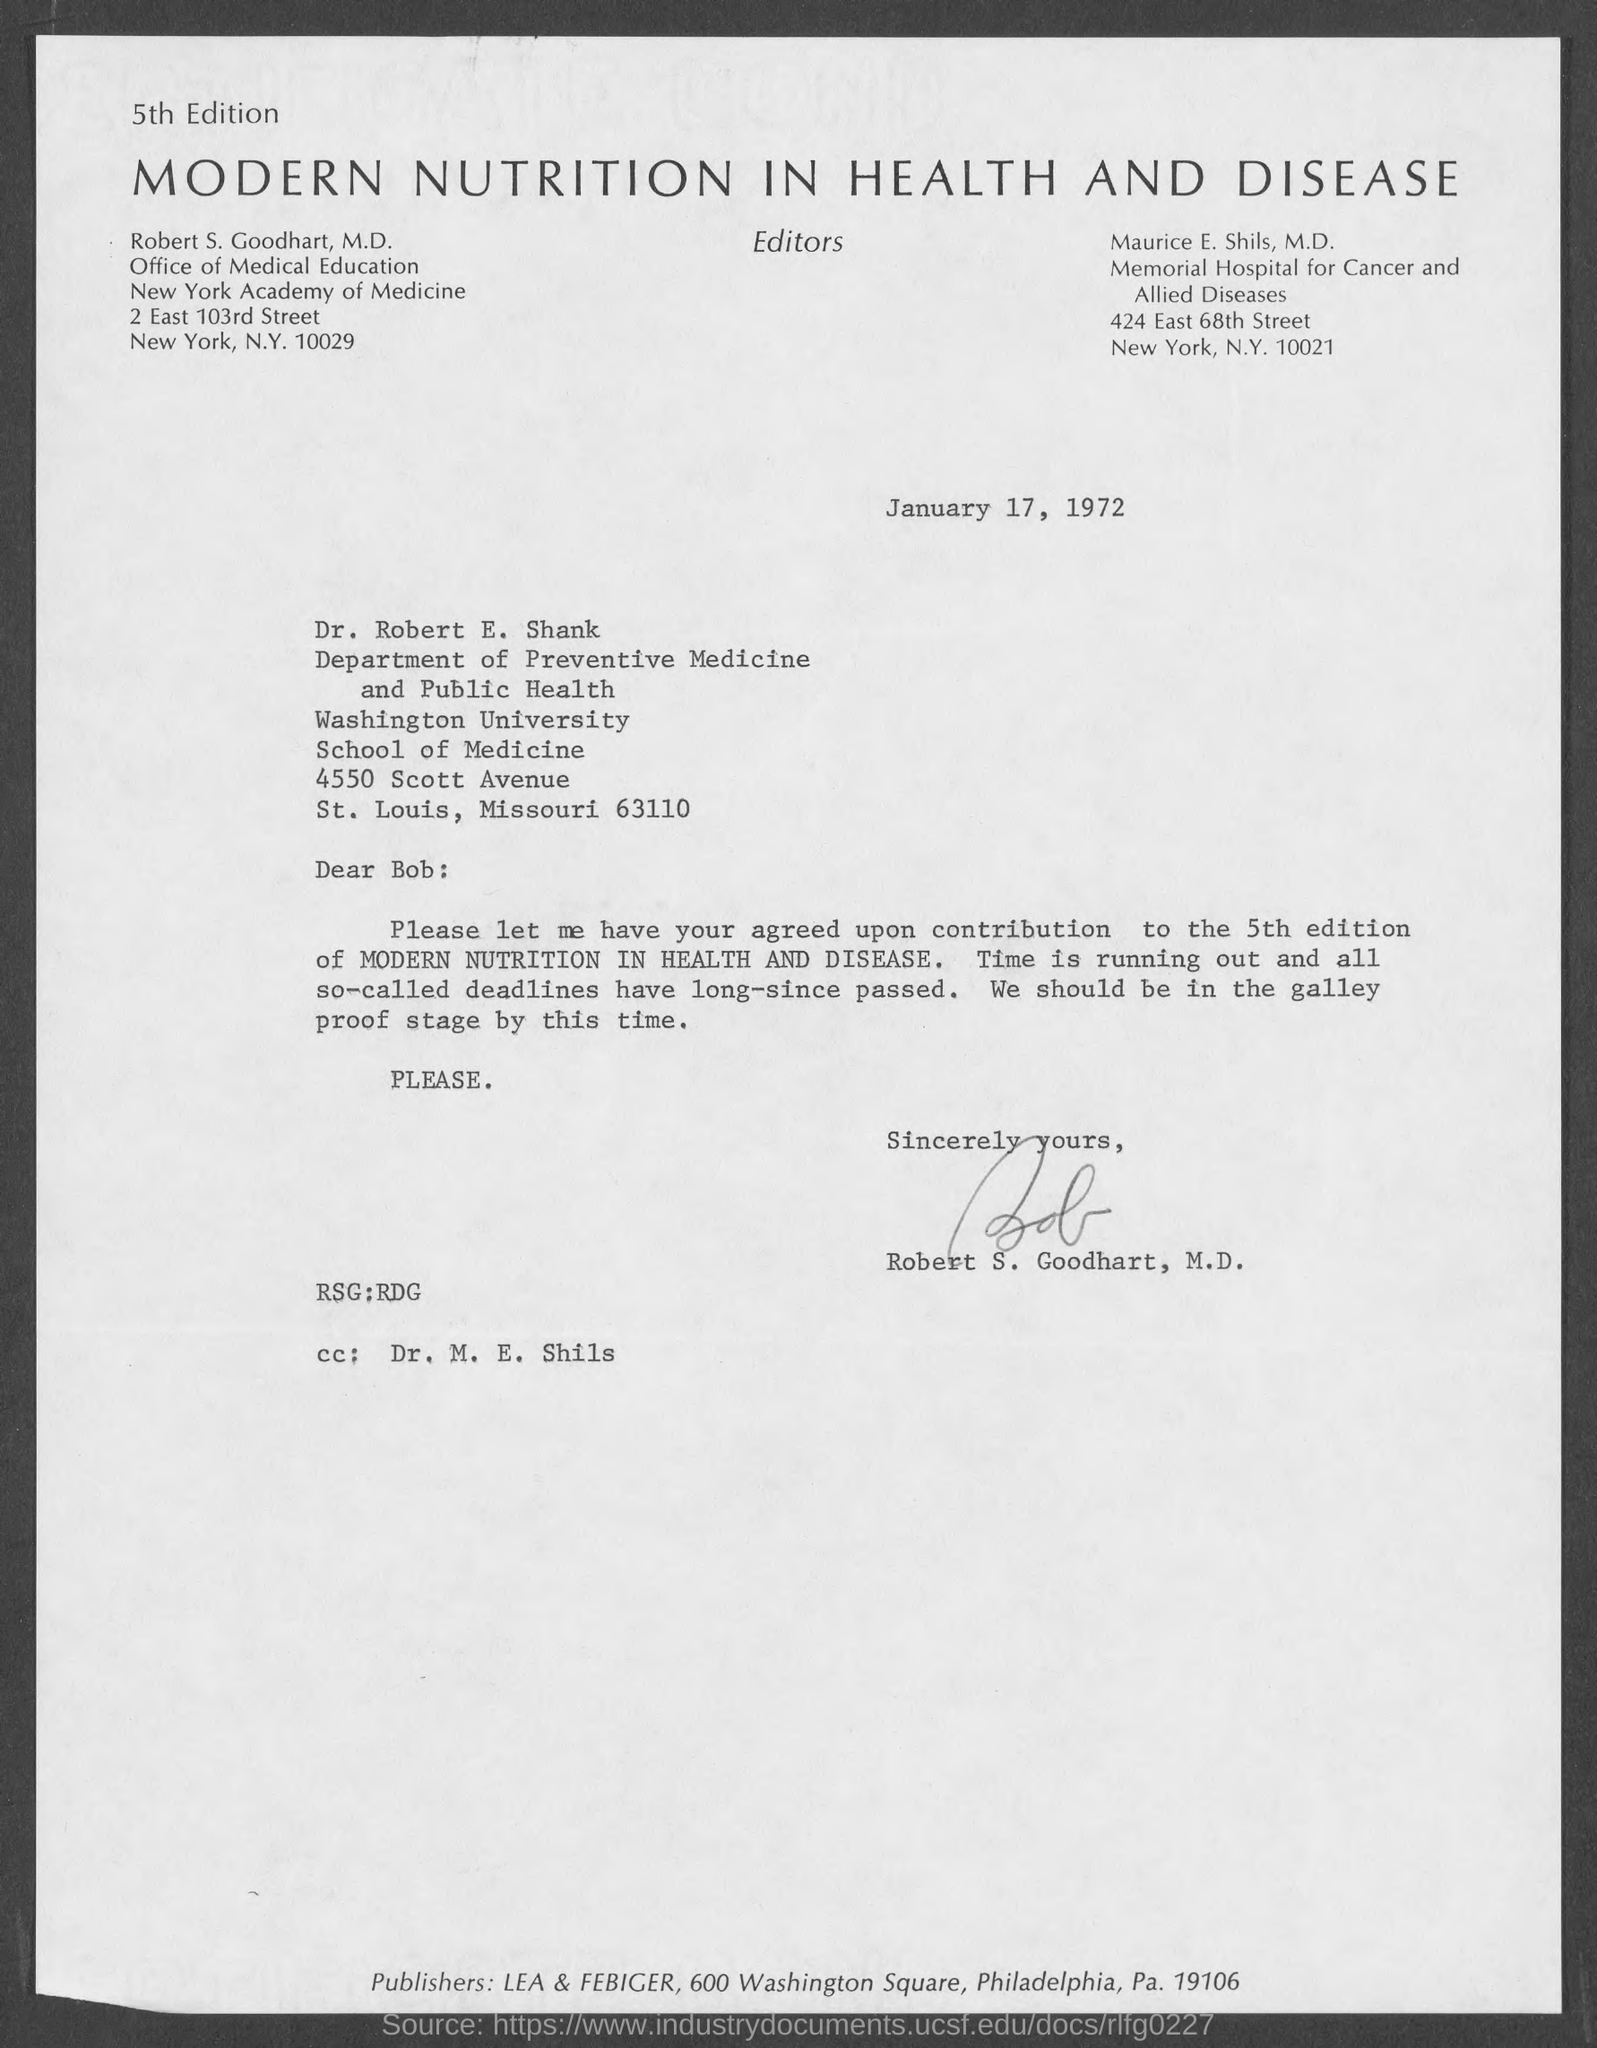To which department does Dr.Robert E. Shank belong to?
Your answer should be very brief. DEPARTMENT OF PREVENTIVE MEDICINE AND PUBLIC HEALTH. Who wrote this letter?
Your response must be concise. Robert S. Goodhart, M.D. The letter is dated on?
Ensure brevity in your answer.  January 17, 1972. 